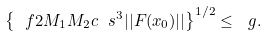Convert formula to latex. <formula><loc_0><loc_0><loc_500><loc_500>\left \{ \ f { 2 M _ { 1 } M _ { 2 } } { c } \ s ^ { 3 } | | F ( x _ { 0 } ) | | \right \} ^ { 1 / 2 } \leq \ g .</formula> 